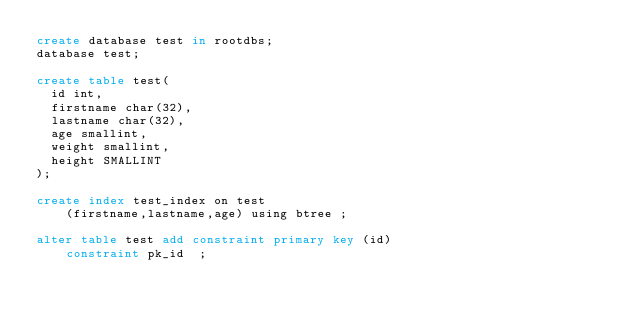Convert code to text. <code><loc_0><loc_0><loc_500><loc_500><_SQL_>create database test in rootdbs;
database test;

create table test(
  id int,
  firstname char(32),
  lastname char(32),
  age smallint,
  weight smallint,
  height SMALLINT
);

create index test_index on test
    (firstname,lastname,age) using btree ;

alter table test add constraint primary key (id)
    constraint pk_id  ;</code> 